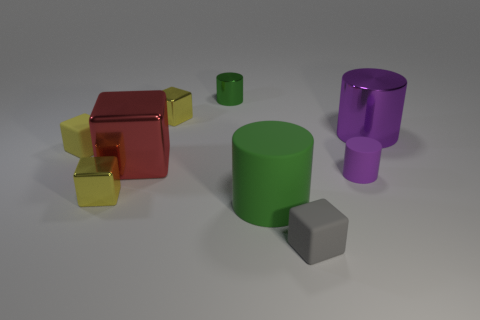Which object stands out the most to you and why? The large red cube stands out the most due to its bright, reflective surface that contrasts with the matte textures of the other objects, as well as its prominent position in the foreground of the image. Can you describe the texture of that red cube? The texture of the red cube appears to be very smooth and reflective, almost like polished glass or a glossy plastic, which gives it a highly specular surface that catches the light and creates reflections. 